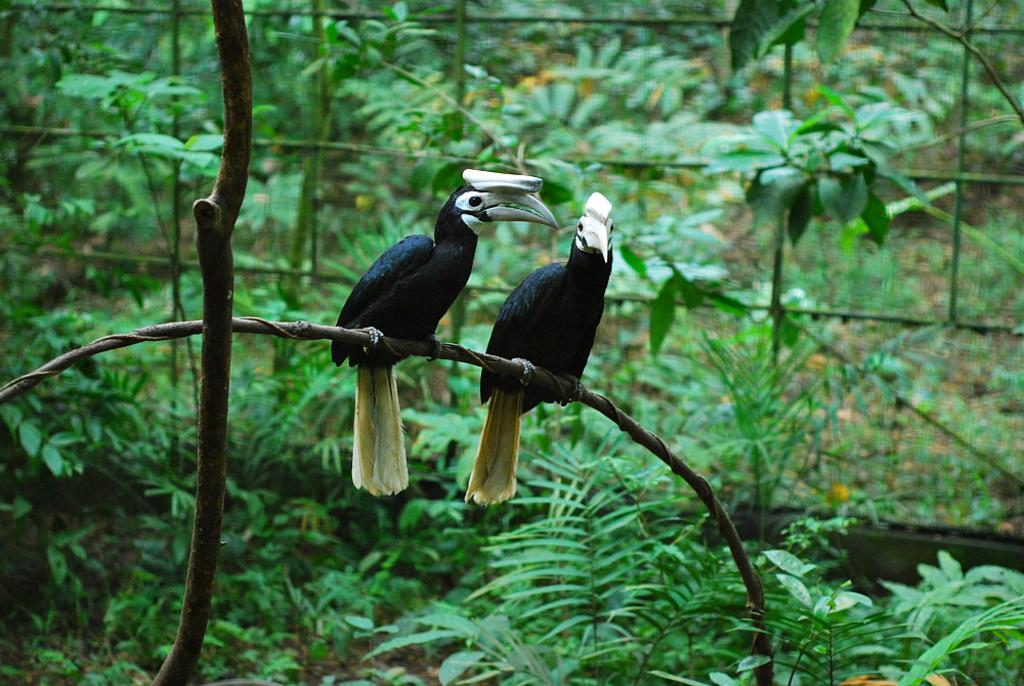What is the main subject of the image? The main subject of the image is a stem. What is located on the stem? There are two black colored birds with white beaks on the stem. What can be seen in the background of the image? There are many trees in the background of the image. Can you tell me how many times the birds kiss each other in the image? There is no indication of the birds kissing each other in the image. 